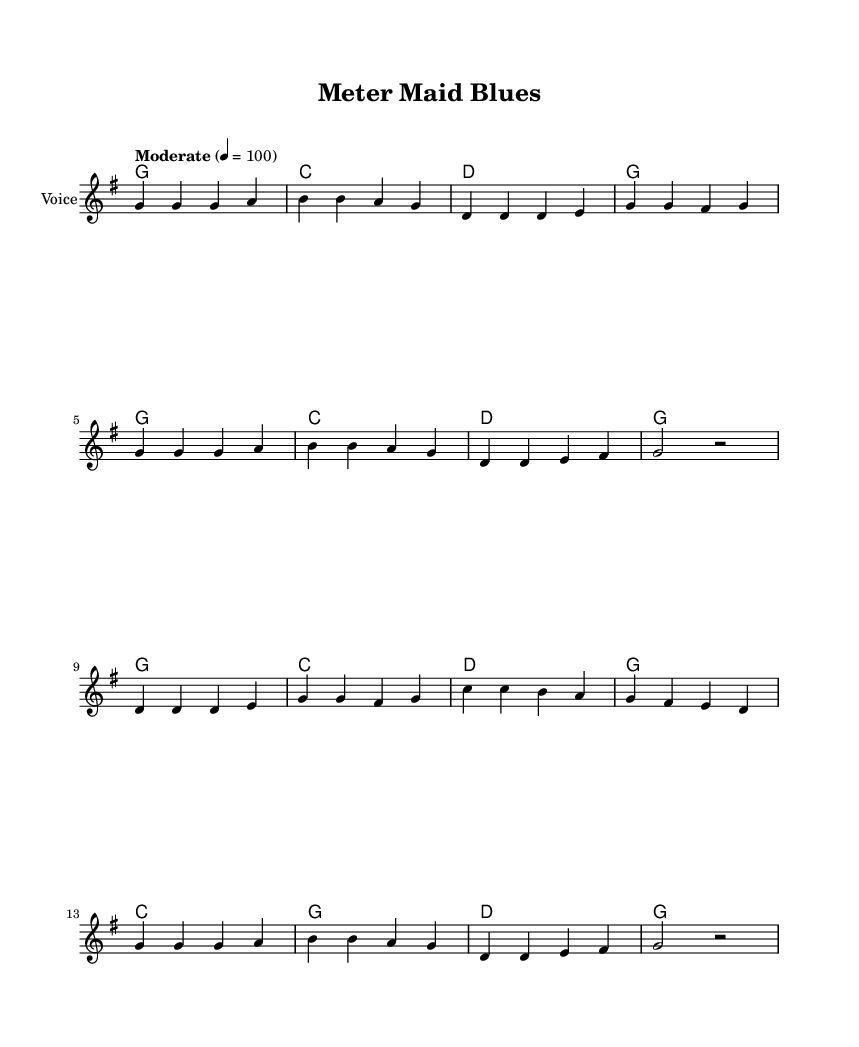What is the key signature of this music? The key signature is G major, which has one sharp (F#). This can be determined by looking at the key signature notation at the beginning of the staff.
Answer: G major What is the time signature of the piece? The time signature is 4/4, indicated at the beginning of the score. This means there are four beats in a measure and the quarter note gets one beat.
Answer: 4/4 What is the tempo marking for this piece? The tempo marking indicates a "Moderate" pace with a metronome marking of 100 beats per minute. This is located near the beginning of the score, typically above the staff.
Answer: Moderate 4 = 100 How many measures are in the chorus? The chorus consists of eight measures, as can be counted by looking at the alignment of the notation in the sheet music specifically for the section labeled "Chorus."
Answer: 8 What is the main theme expressed in the lyrics? The main theme expressed in the lyrics revolves around frustrations with parking enforcement in Grand Rapids, contrasting it with a longing for rural life. This theme can be inferred from both the chorus and verse lyrics.
Answer: Parking enforcement frustrations How many different chords are used in the score? The score includes five distinct chords: G, C, D, E, and A. Counting the chord notations in the "harmonies" section shows there are combinations and repetitions of these chord types.
Answer: 5 What kind of song structure is used in this piece? The piece follows a verse-chorus structure, where the lyrics are separated into verses and a repeating chorus. This format is common in country music and can be identified by the labeling of the sections in the score.
Answer: Verse-Chorus 